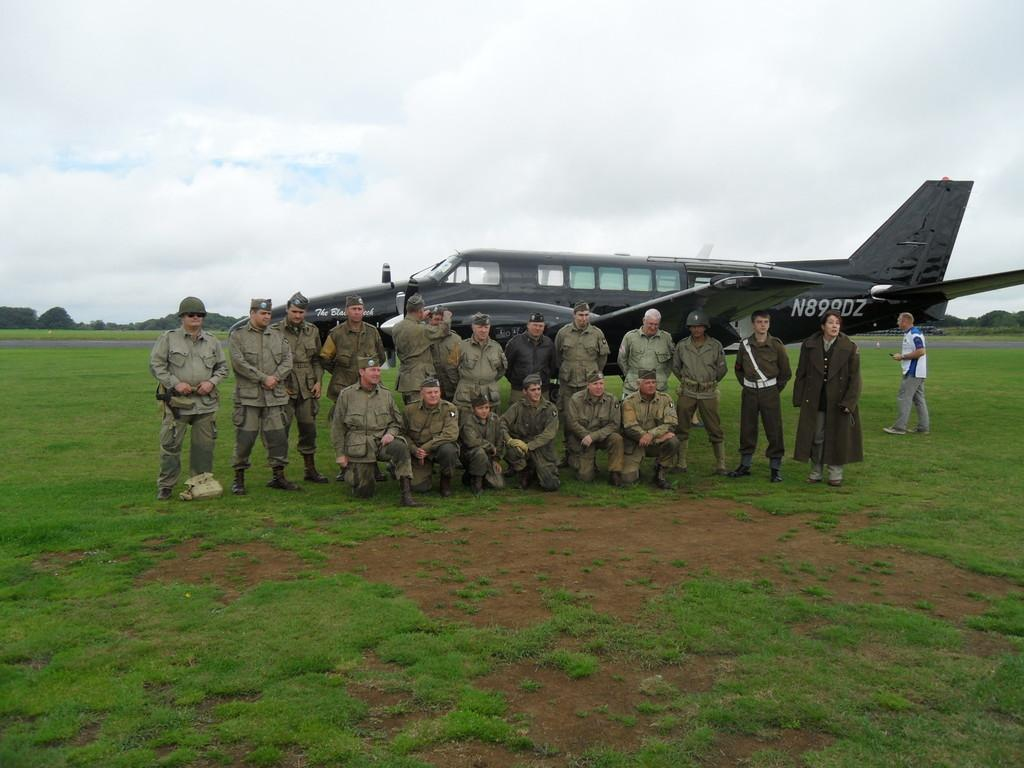<image>
Provide a brief description of the given image. Military men are posing in front of a plane with the marking N899DZ on the side. 